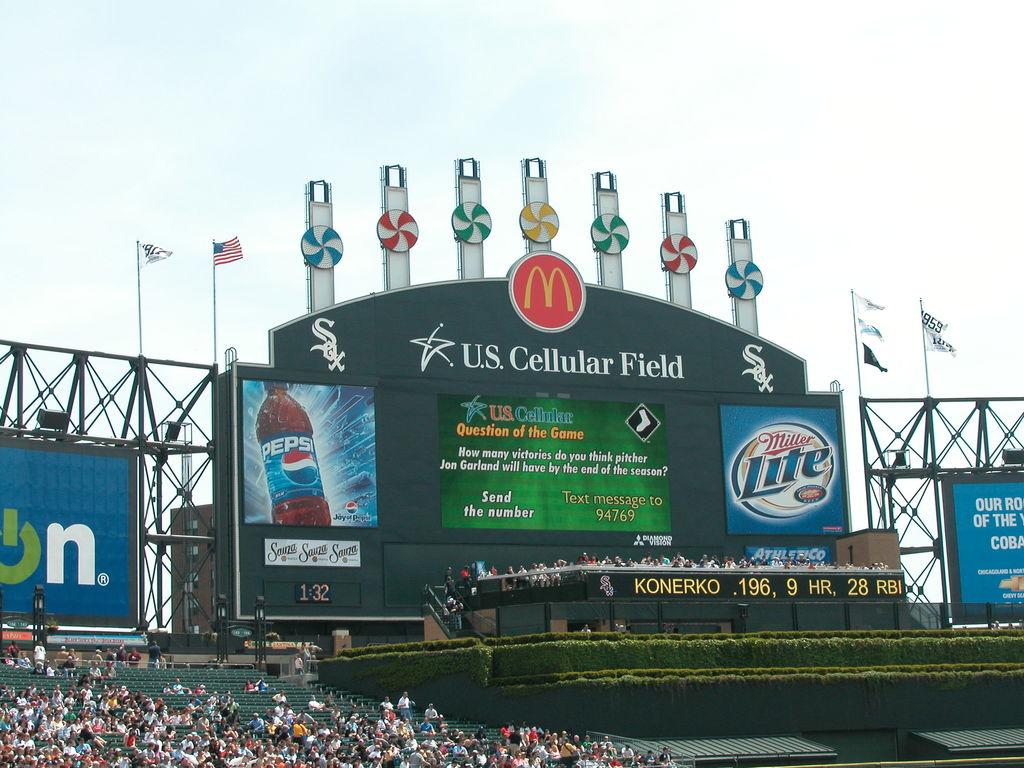Is pepsi a sponsor?
Offer a terse response. Yes. What does the big letters on top of the black poster say?
Make the answer very short. U.s. cellular field. 